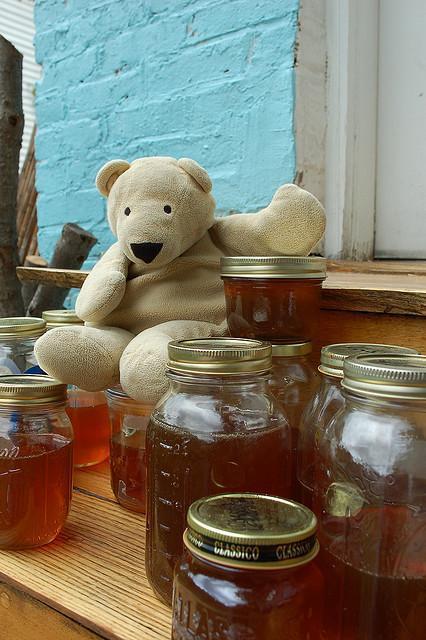How many bottles can you see?
Give a very brief answer. 8. 